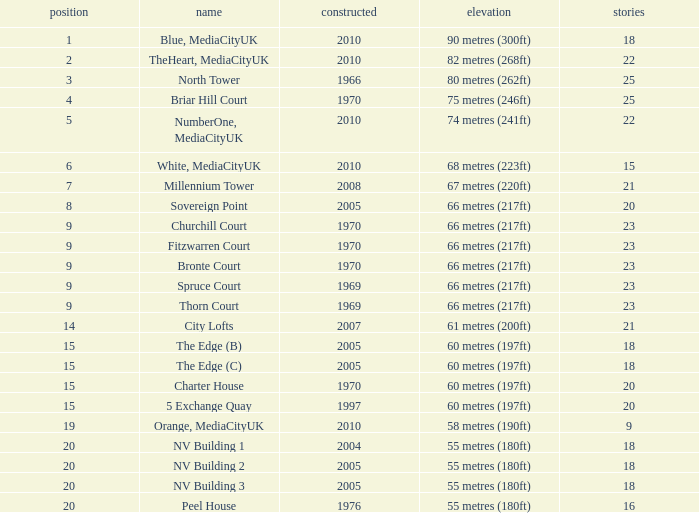What is the total number of Built, when Floors is less than 22, when Rank is less than 8, and when Name is White, Mediacityuk? 1.0. 